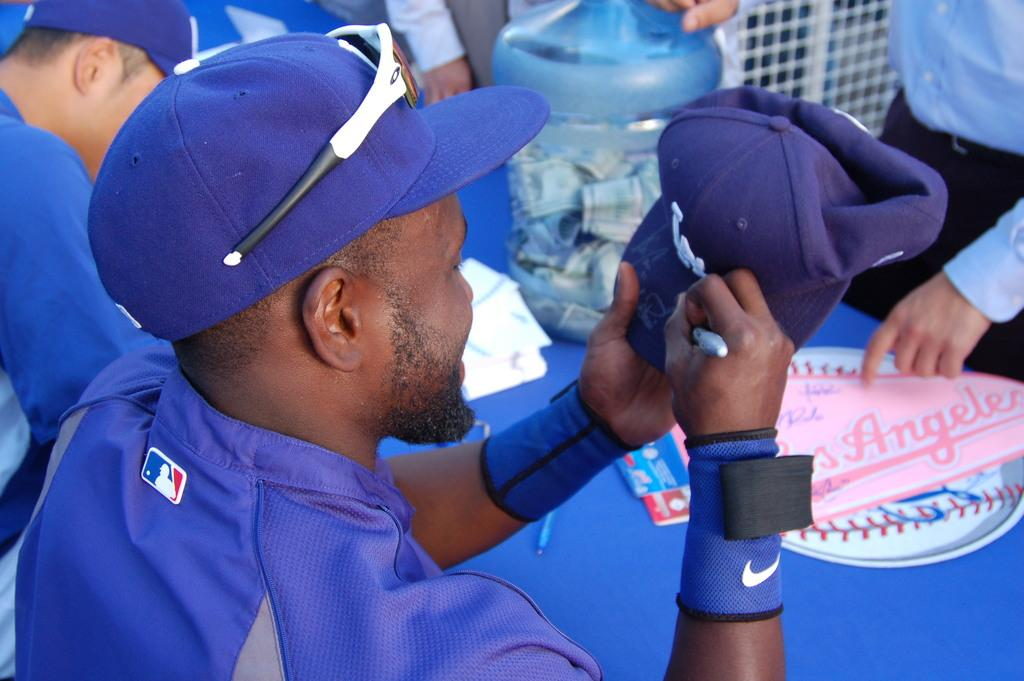What is the man in the image wearing on his upper body? The man is wearing a blue jersey. What is the man wearing on his head? The man is wearing a cap. What is the man doing with the cap in the image? The man is signing on another cap. How many people are visible in the background of the image? There are many people standing in the background. What can be seen on the table in the background? There is a plate and a bottle of cash on the table. How many ants are crawling on the man's cap in the image? There are no ants visible on the man's cap in the image. What type of rings can be seen on the man's fingers in the image? There is no mention of rings on the man's fingers in the image. 